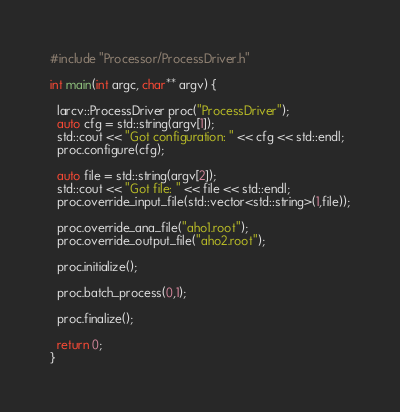<code> <loc_0><loc_0><loc_500><loc_500><_C++_>#include "Processor/ProcessDriver.h"

int main(int argc, char** argv) {

  larcv::ProcessDriver proc("ProcessDriver");
  auto cfg = std::string(argv[1]);
  std::cout << "Got configuration: " << cfg << std::endl;
  proc.configure(cfg);
  
  auto file = std::string(argv[2]);
  std::cout << "Got file: " << file << std::endl;
  proc.override_input_file(std::vector<std::string>(1,file));

  proc.override_ana_file("aho1.root");
  proc.override_output_file("aho2.root");

  proc.initialize();

  proc.batch_process(0,1);

  proc.finalize();

  return 0;
}
</code> 